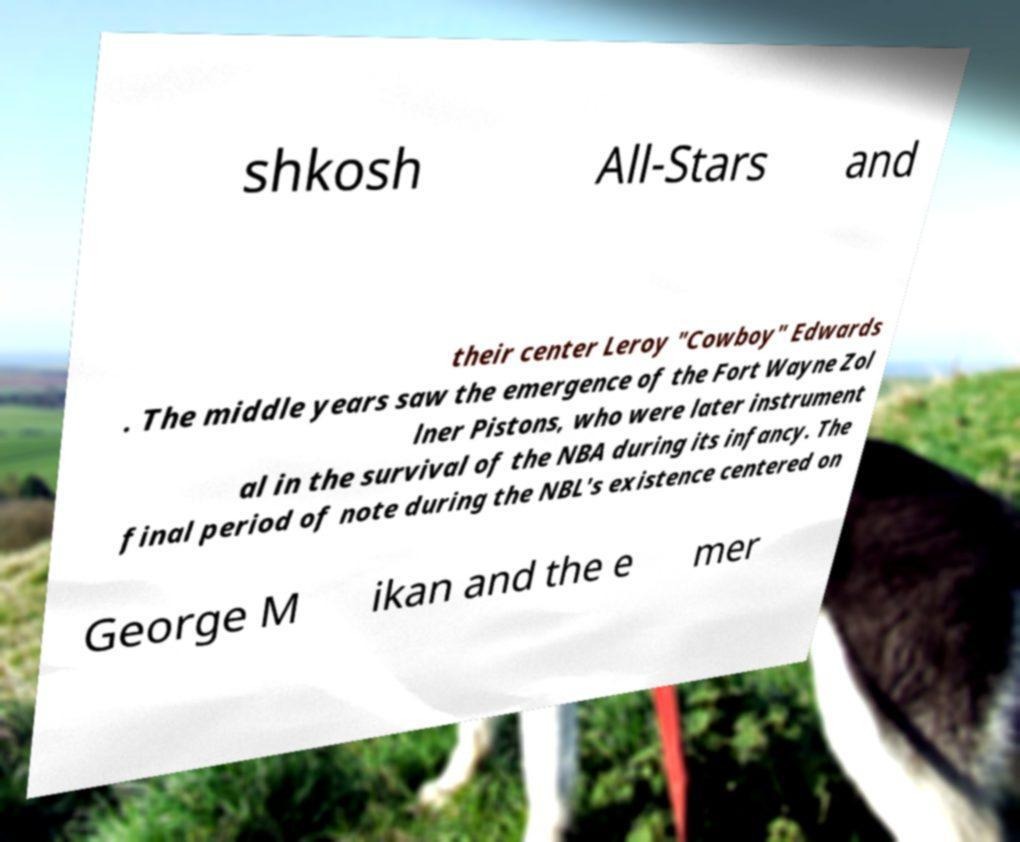What messages or text are displayed in this image? I need them in a readable, typed format. shkosh All-Stars and their center Leroy "Cowboy" Edwards . The middle years saw the emergence of the Fort Wayne Zol lner Pistons, who were later instrument al in the survival of the NBA during its infancy. The final period of note during the NBL's existence centered on George M ikan and the e mer 